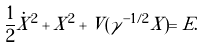Convert formula to latex. <formula><loc_0><loc_0><loc_500><loc_500>\frac { 1 } { 2 } \dot { X } ^ { 2 } + X ^ { 2 } + V ( \gamma ^ { - 1 / 2 } X ) = E .</formula> 